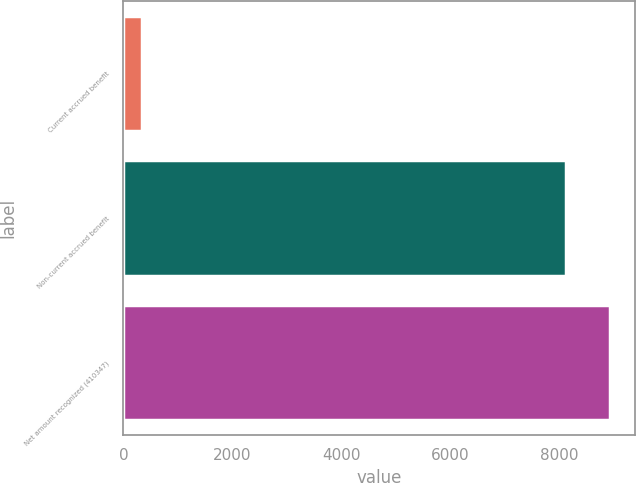Convert chart. <chart><loc_0><loc_0><loc_500><loc_500><bar_chart><fcel>Current accrued benefit<fcel>Non-current accrued benefit<fcel>Net amount recognized (410347)<nl><fcel>333<fcel>8128<fcel>8940.8<nl></chart> 